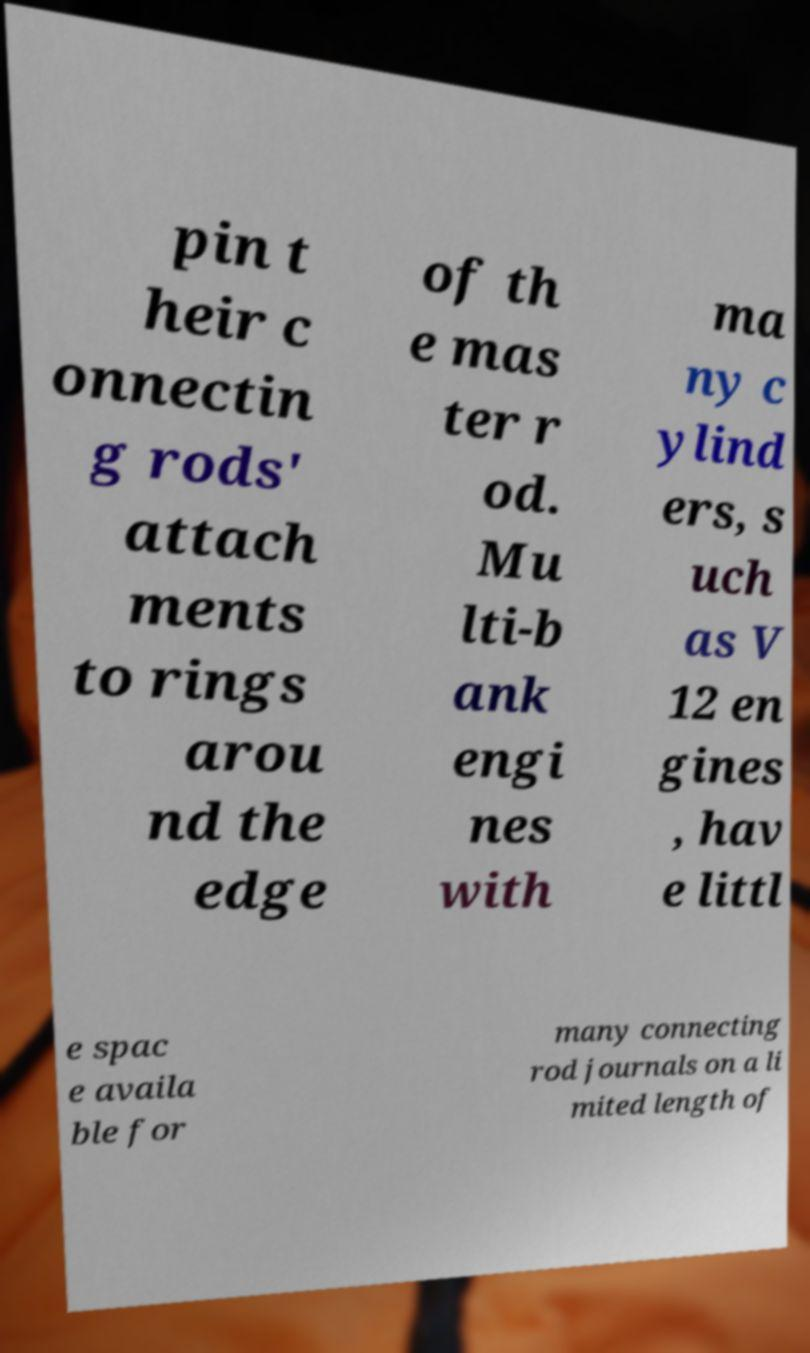There's text embedded in this image that I need extracted. Can you transcribe it verbatim? pin t heir c onnectin g rods' attach ments to rings arou nd the edge of th e mas ter r od. Mu lti-b ank engi nes with ma ny c ylind ers, s uch as V 12 en gines , hav e littl e spac e availa ble for many connecting rod journals on a li mited length of 